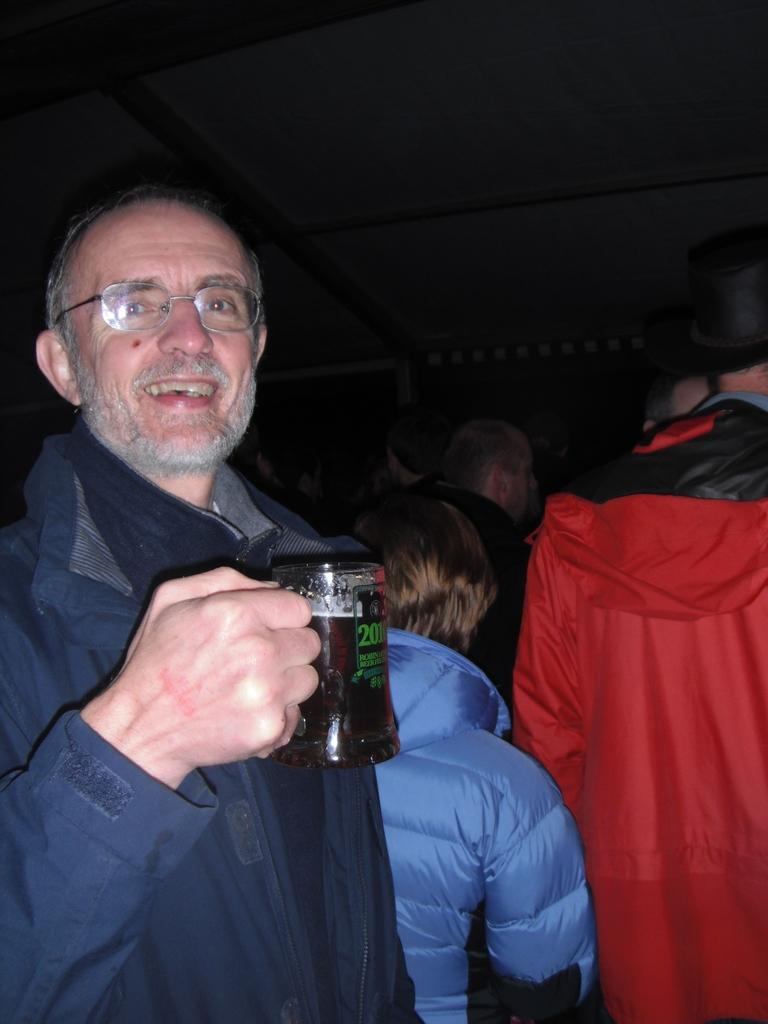What is the main subject of the image? There is a person in the image. What is the person doing in the image? The person is smiling and holding a glass. Are there any other people visible in the image? Yes, there are many people standing to the left of the person. What type of machine is generating heat in the image? There is no machine or heat present in the image; it features a person smiling and holding a glass, with other people standing nearby. Can you see any worms crawling on the person in the image? No, there are no worms visible in the image. 